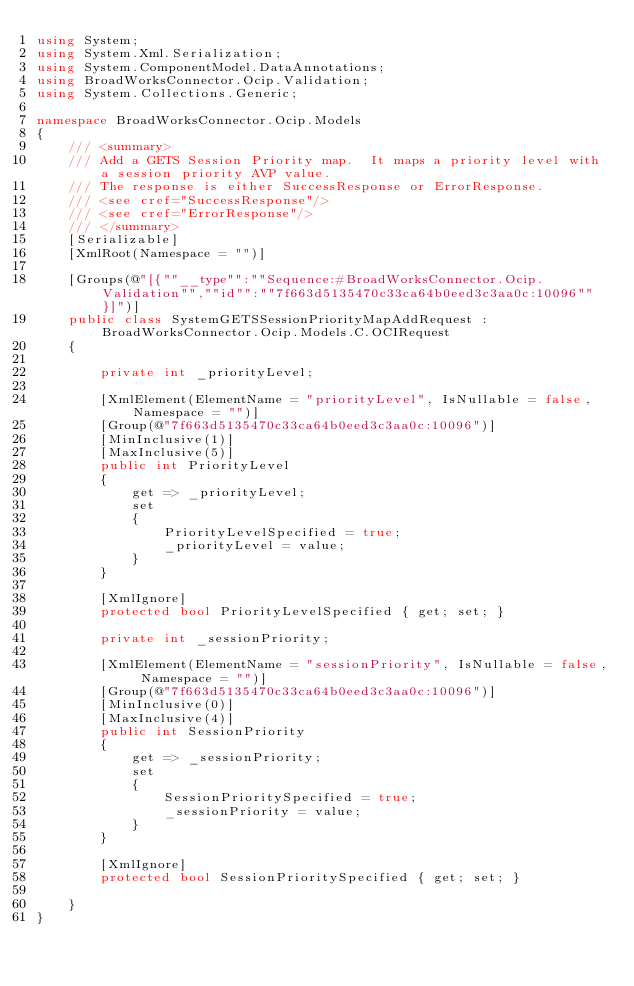Convert code to text. <code><loc_0><loc_0><loc_500><loc_500><_C#_>using System;
using System.Xml.Serialization;
using System.ComponentModel.DataAnnotations;
using BroadWorksConnector.Ocip.Validation;
using System.Collections.Generic;

namespace BroadWorksConnector.Ocip.Models
{
    /// <summary>
    /// Add a GETS Session Priority map.  It maps a priority level with a session priority AVP value.
    /// The response is either SuccessResponse or ErrorResponse.
    /// <see cref="SuccessResponse"/>
    /// <see cref="ErrorResponse"/>
    /// </summary>
    [Serializable]
    [XmlRoot(Namespace = "")]

    [Groups(@"[{""__type"":""Sequence:#BroadWorksConnector.Ocip.Validation"",""id"":""7f663d5135470c33ca64b0eed3c3aa0c:10096""}]")]
    public class SystemGETSSessionPriorityMapAddRequest : BroadWorksConnector.Ocip.Models.C.OCIRequest
    {

        private int _priorityLevel;

        [XmlElement(ElementName = "priorityLevel", IsNullable = false, Namespace = "")]
        [Group(@"7f663d5135470c33ca64b0eed3c3aa0c:10096")]
        [MinInclusive(1)]
        [MaxInclusive(5)]
        public int PriorityLevel
        {
            get => _priorityLevel;
            set
            {
                PriorityLevelSpecified = true;
                _priorityLevel = value;
            }
        }

        [XmlIgnore]
        protected bool PriorityLevelSpecified { get; set; }

        private int _sessionPriority;

        [XmlElement(ElementName = "sessionPriority", IsNullable = false, Namespace = "")]
        [Group(@"7f663d5135470c33ca64b0eed3c3aa0c:10096")]
        [MinInclusive(0)]
        [MaxInclusive(4)]
        public int SessionPriority
        {
            get => _sessionPriority;
            set
            {
                SessionPrioritySpecified = true;
                _sessionPriority = value;
            }
        }

        [XmlIgnore]
        protected bool SessionPrioritySpecified { get; set; }

    }
}
</code> 